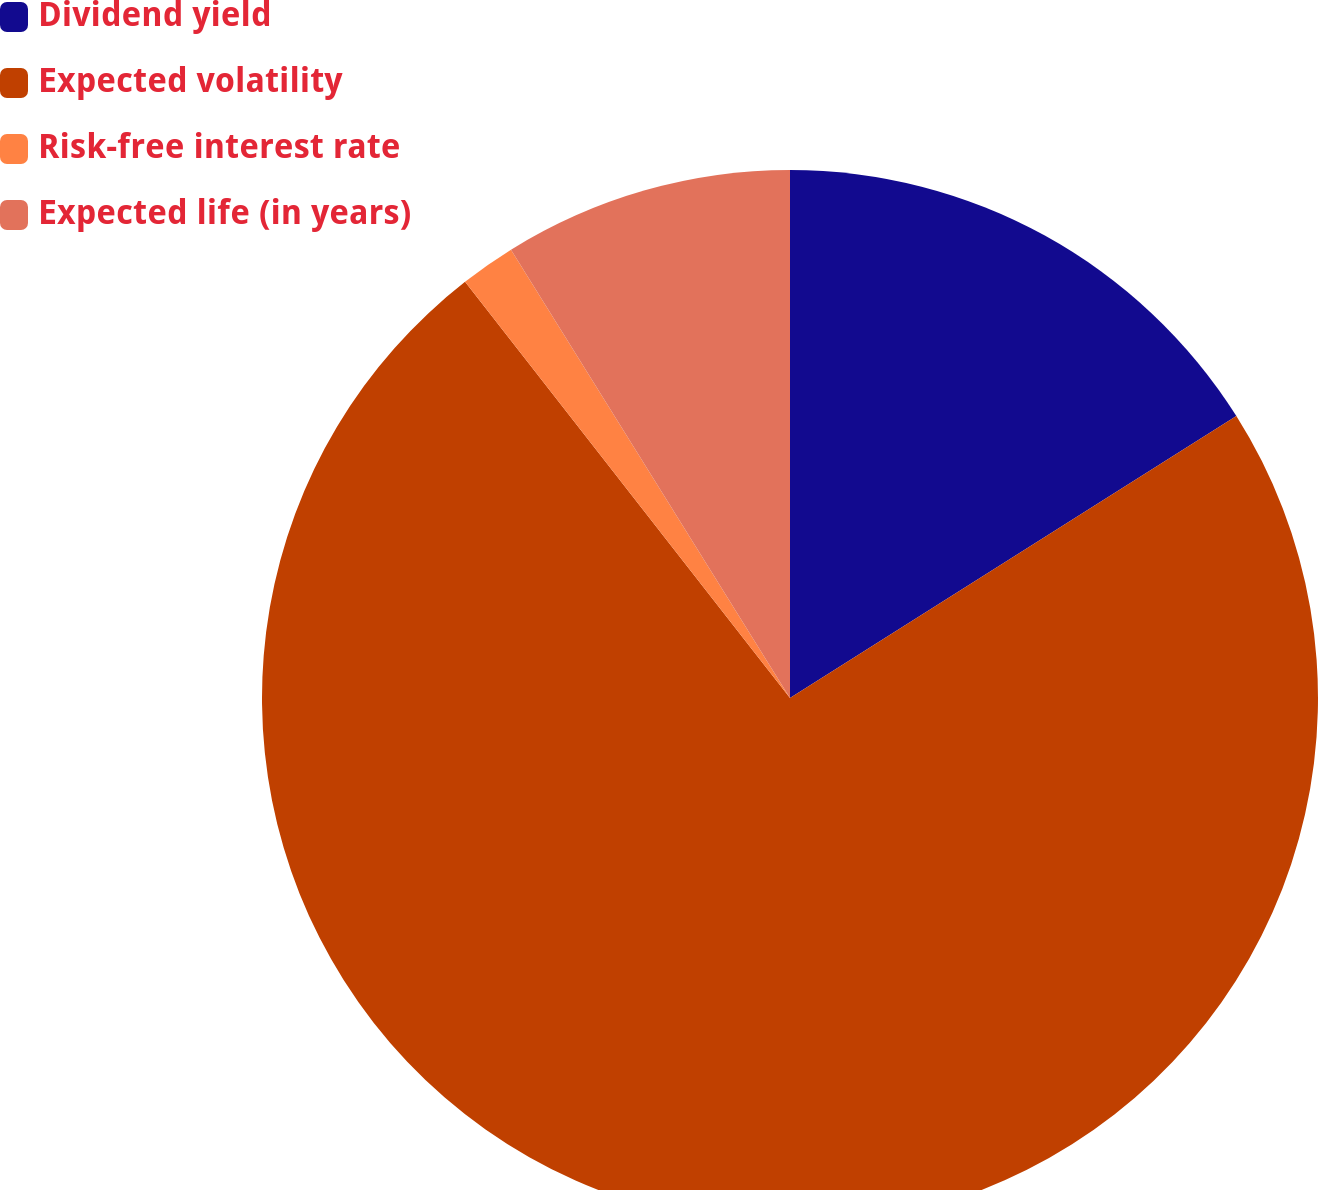Convert chart to OTSL. <chart><loc_0><loc_0><loc_500><loc_500><pie_chart><fcel>Dividend yield<fcel>Expected volatility<fcel>Risk-free interest rate<fcel>Expected life (in years)<nl><fcel>16.03%<fcel>73.41%<fcel>1.69%<fcel>8.86%<nl></chart> 